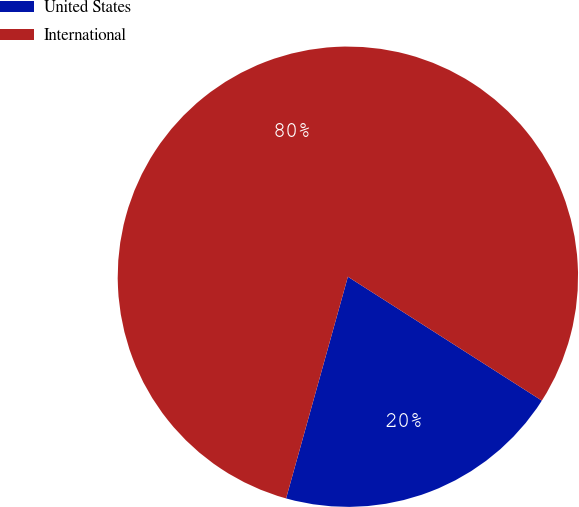<chart> <loc_0><loc_0><loc_500><loc_500><pie_chart><fcel>United States<fcel>International<nl><fcel>20.28%<fcel>79.72%<nl></chart> 